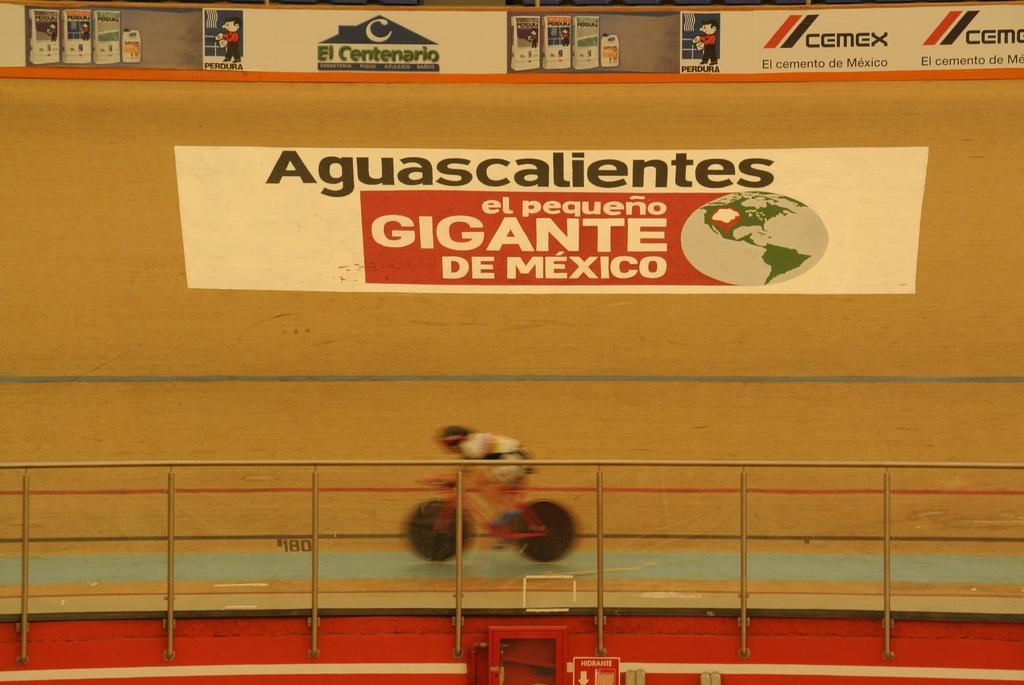How would you summarize this image in a sentence or two? In the picture I can see a person riding a bicycle on the curved surface. I can see the stainless steel glass fencing at the bottom of the picture. I can see the painting on the wooden curved surface. I can see the product advertising hoardings at the top of the picture. 